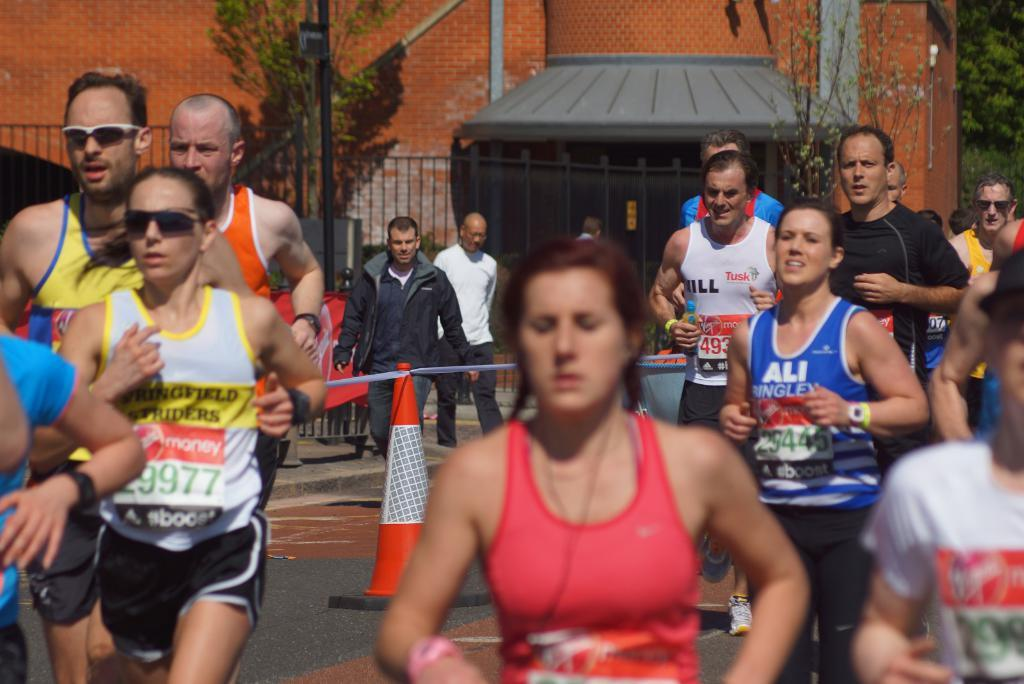<image>
Create a compact narrative representing the image presented. Men and women running a race wearing sponsors names such as Tusk on their shirts. 